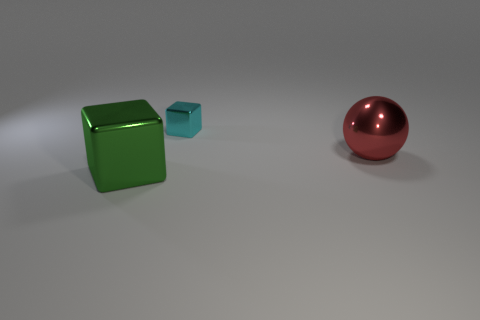How many other things are there of the same size as the red metallic ball?
Your answer should be very brief. 1. There is a thing that is behind the large green object and left of the large red sphere; what material is it?
Provide a succinct answer. Metal. Is the size of the block that is on the right side of the green shiny cube the same as the red thing?
Provide a short and direct response. No. Is the color of the tiny shiny object the same as the big metallic cube?
Make the answer very short. No. How many blocks are both on the right side of the large green thing and in front of the big red metal sphere?
Keep it short and to the point. 0. What number of green cubes are behind the large thing that is to the left of the big object behind the large cube?
Keep it short and to the point. 0. What is the shape of the small object?
Offer a terse response. Cube. How many large red things have the same material as the cyan thing?
Offer a terse response. 1. What color is the other block that is made of the same material as the cyan block?
Your response must be concise. Green. There is a green metallic thing; is its size the same as the shiny object to the right of the tiny metal thing?
Provide a succinct answer. Yes. 